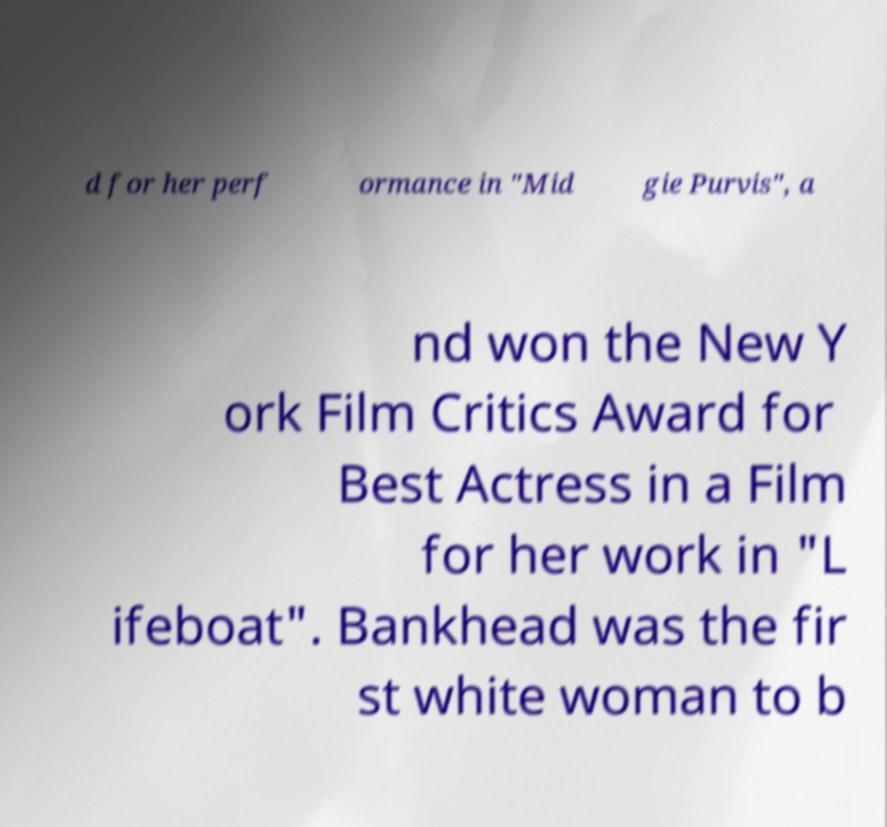Please identify and transcribe the text found in this image. d for her perf ormance in "Mid gie Purvis", a nd won the New Y ork Film Critics Award for Best Actress in a Film for her work in "L ifeboat". Bankhead was the fir st white woman to b 